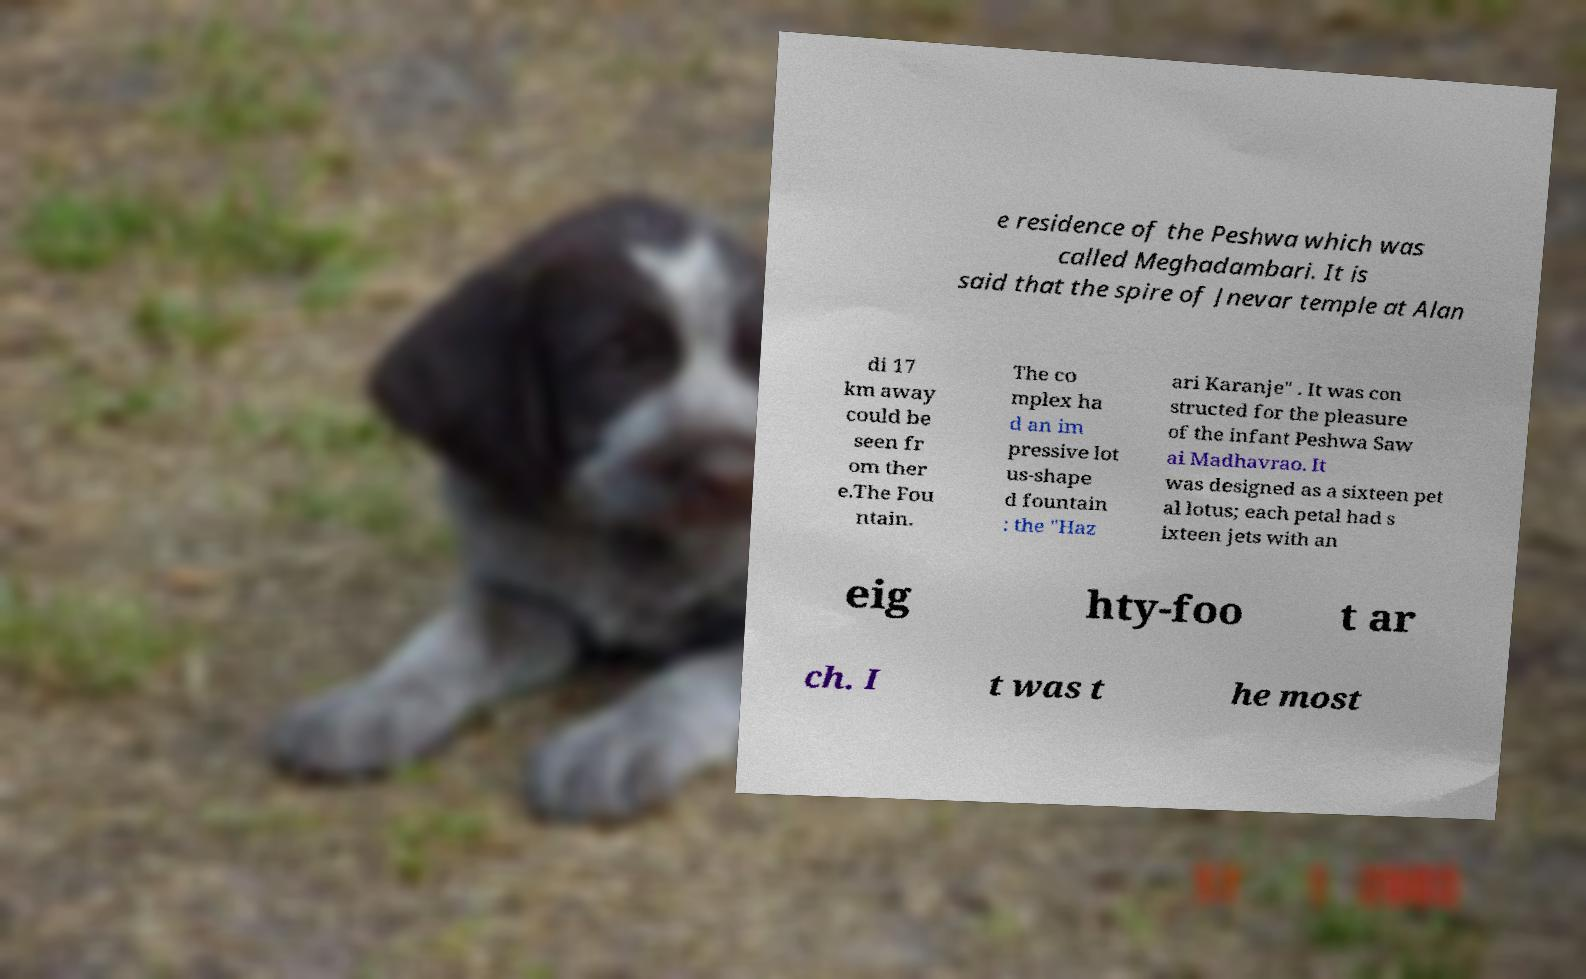What messages or text are displayed in this image? I need them in a readable, typed format. e residence of the Peshwa which was called Meghadambari. It is said that the spire of Jnevar temple at Alan di 17 km away could be seen fr om ther e.The Fou ntain. The co mplex ha d an im pressive lot us-shape d fountain : the "Haz ari Karanje" . It was con structed for the pleasure of the infant Peshwa Saw ai Madhavrao. It was designed as a sixteen pet al lotus; each petal had s ixteen jets with an eig hty-foo t ar ch. I t was t he most 